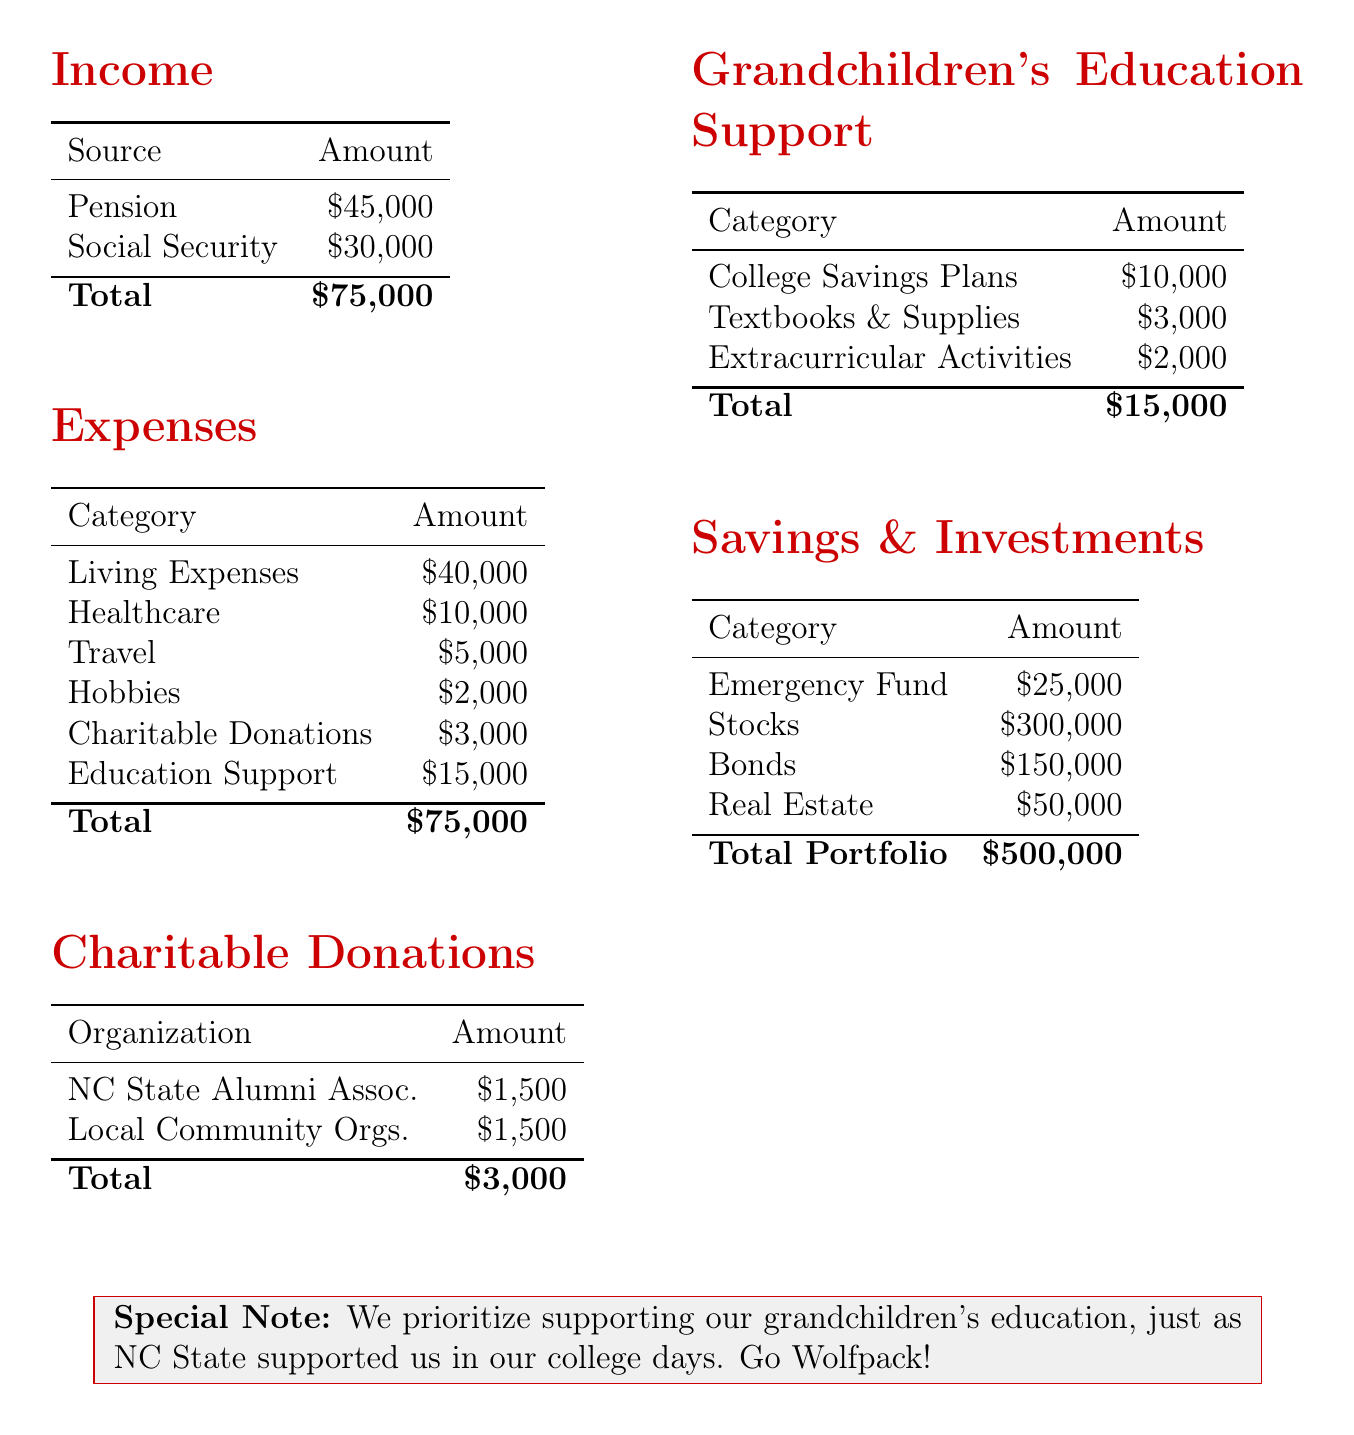what is the total annual income? The total annual income is the sum of pension and social security amounts, which is $45,000 + $30,000 = $75,000.
Answer: $75,000 how much do John and Mary allocate for their grandchildren's education support? The document specifies a total of $15,000 for grandchildren's education support.
Answer: $15,000 what is the amount set aside for emergencies? The emergency fund amount is clearly stated as $25,000 in the savings section.
Answer: $25,000 how much do John and Mary donate to the NC State Alumni Association? The document indicates that they donate $1,500 to the NC State Alumni Association.
Answer: $1,500 what percentage of their total expenses goes to grandchildren's education support? The allocation for grandchildren's education support is $15,000 out of total expenses of $75,000, which is 20%.
Answer: 20% how much do they allocate for hobbies? The hobbies expense is listed as $2,000 in the expenses section.
Answer: $2,000 what is the total value of their investment portfolio? The total value of their investment portfolio is stated as $500,000 in the savings section.
Answer: $500,000 what year did John and Mary graduate from NC State? The document mentions that they graduated in the year 1965.
Answer: 1965 which area has the highest allocation in expenses? The highest allocation in expenses is for living expenses, which is $40,000.
Answer: living expenses 